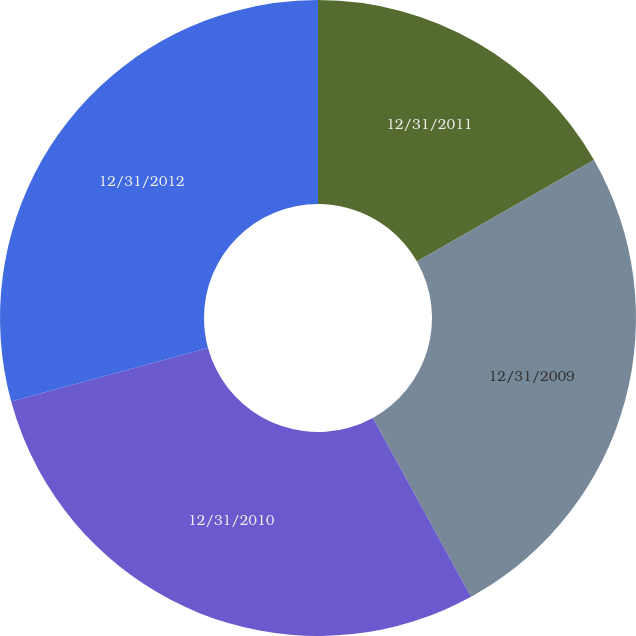<chart> <loc_0><loc_0><loc_500><loc_500><pie_chart><fcel>12/31/2011<fcel>12/31/2009<fcel>12/31/2010<fcel>12/31/2012<nl><fcel>16.73%<fcel>25.28%<fcel>28.76%<fcel>29.23%<nl></chart> 